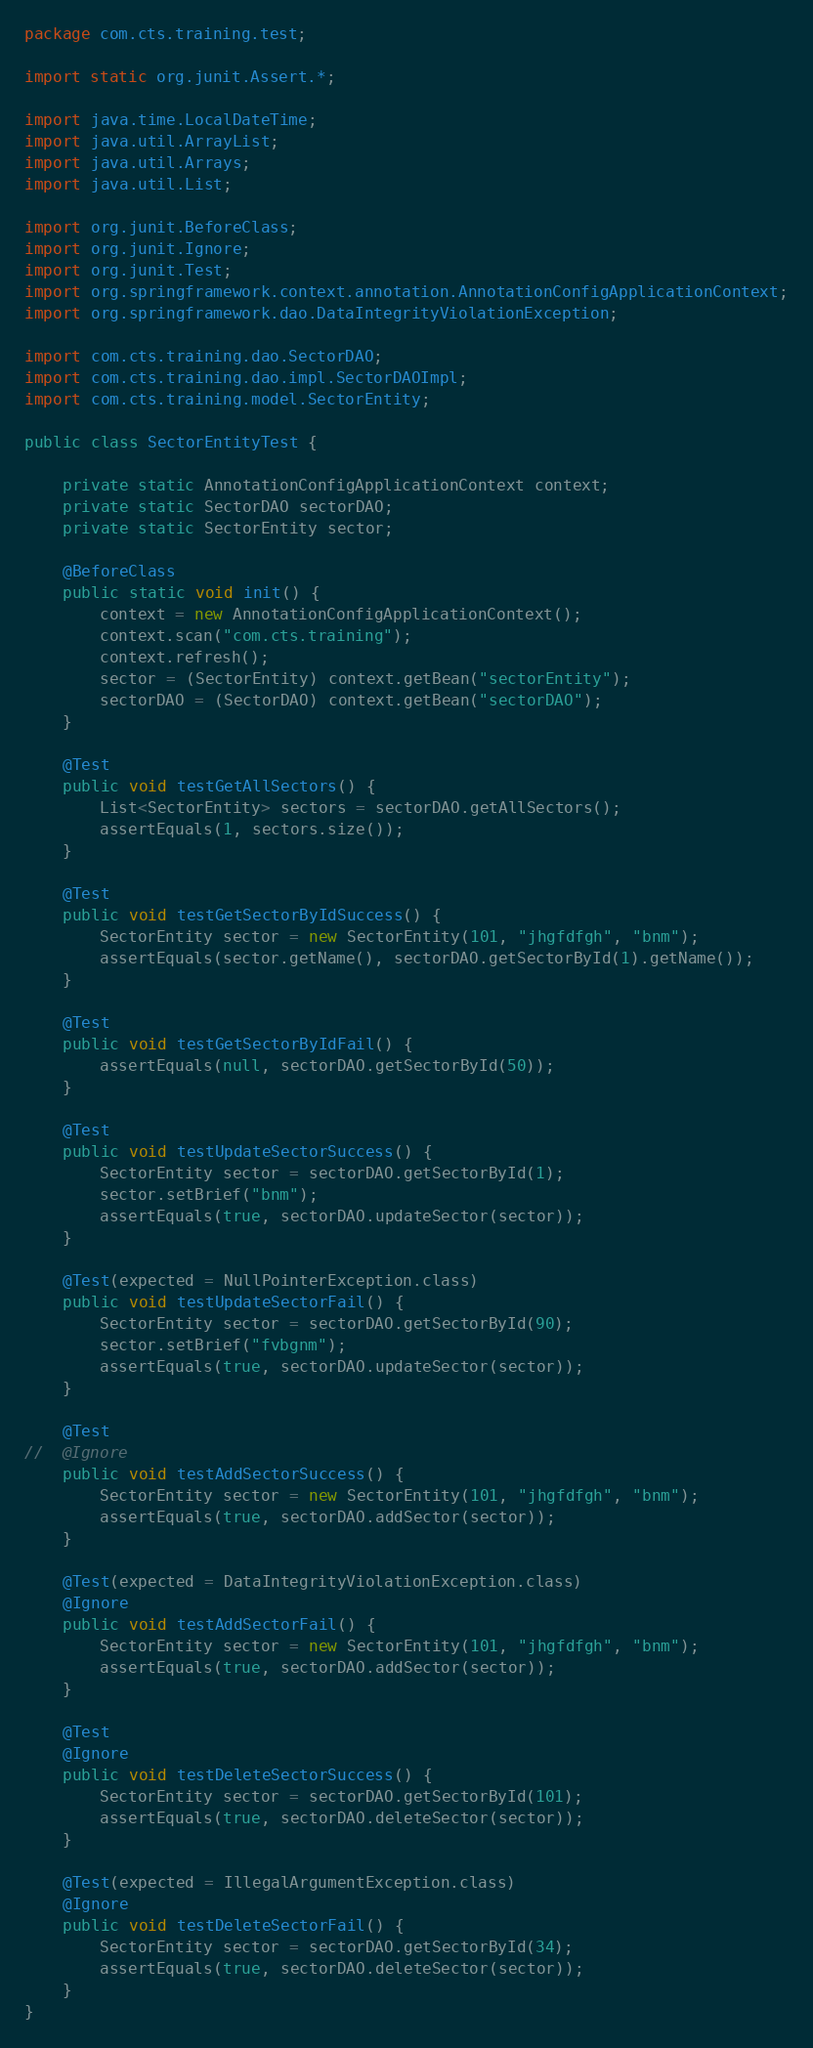<code> <loc_0><loc_0><loc_500><loc_500><_Java_>package com.cts.training.test;

import static org.junit.Assert.*;

import java.time.LocalDateTime;
import java.util.ArrayList;
import java.util.Arrays;
import java.util.List;

import org.junit.BeforeClass;
import org.junit.Ignore;
import org.junit.Test;
import org.springframework.context.annotation.AnnotationConfigApplicationContext;
import org.springframework.dao.DataIntegrityViolationException;

import com.cts.training.dao.SectorDAO;
import com.cts.training.dao.impl.SectorDAOImpl;
import com.cts.training.model.SectorEntity;

public class SectorEntityTest {

	private static AnnotationConfigApplicationContext context;
	private static SectorDAO sectorDAO;
	private static SectorEntity sector;

	@BeforeClass
	public static void init() {
		context = new AnnotationConfigApplicationContext();
		context.scan("com.cts.training");
		context.refresh();
		sector = (SectorEntity) context.getBean("sectorEntity");
		sectorDAO = (SectorDAO) context.getBean("sectorDAO");
	}

	@Test
	public void testGetAllSectors() {
		List<SectorEntity> sectors = sectorDAO.getAllSectors();
		assertEquals(1, sectors.size());
	}

	@Test
	public void testGetSectorByIdSuccess() {
		SectorEntity sector = new SectorEntity(101, "jhgfdfgh", "bnm");
		assertEquals(sector.getName(), sectorDAO.getSectorById(1).getName());
	}

	@Test
	public void testGetSectorByIdFail() {
		assertEquals(null, sectorDAO.getSectorById(50));
	}

	@Test
	public void testUpdateSectorSuccess() {
		SectorEntity sector = sectorDAO.getSectorById(1);
		sector.setBrief("bnm");
		assertEquals(true, sectorDAO.updateSector(sector));
	}

	@Test(expected = NullPointerException.class)
	public void testUpdateSectorFail() {
		SectorEntity sector = sectorDAO.getSectorById(90);
		sector.setBrief("fvbgnm");
		assertEquals(true, sectorDAO.updateSector(sector));
	}

	@Test
//	@Ignore
	public void testAddSectorSuccess() {
		SectorEntity sector = new SectorEntity(101, "jhgfdfgh", "bnm");
		assertEquals(true, sectorDAO.addSector(sector));
	}

	@Test(expected = DataIntegrityViolationException.class)
	@Ignore
	public void testAddSectorFail() {
		SectorEntity sector = new SectorEntity(101, "jhgfdfgh", "bnm");
		assertEquals(true, sectorDAO.addSector(sector));
	}

	@Test
	@Ignore
	public void testDeleteSectorSuccess() {
		SectorEntity sector = sectorDAO.getSectorById(101);
		assertEquals(true, sectorDAO.deleteSector(sector));
	}

	@Test(expected = IllegalArgumentException.class)
	@Ignore
	public void testDeleteSectorFail() {
		SectorEntity sector = sectorDAO.getSectorById(34);
		assertEquals(true, sectorDAO.deleteSector(sector));
	}
}
</code> 